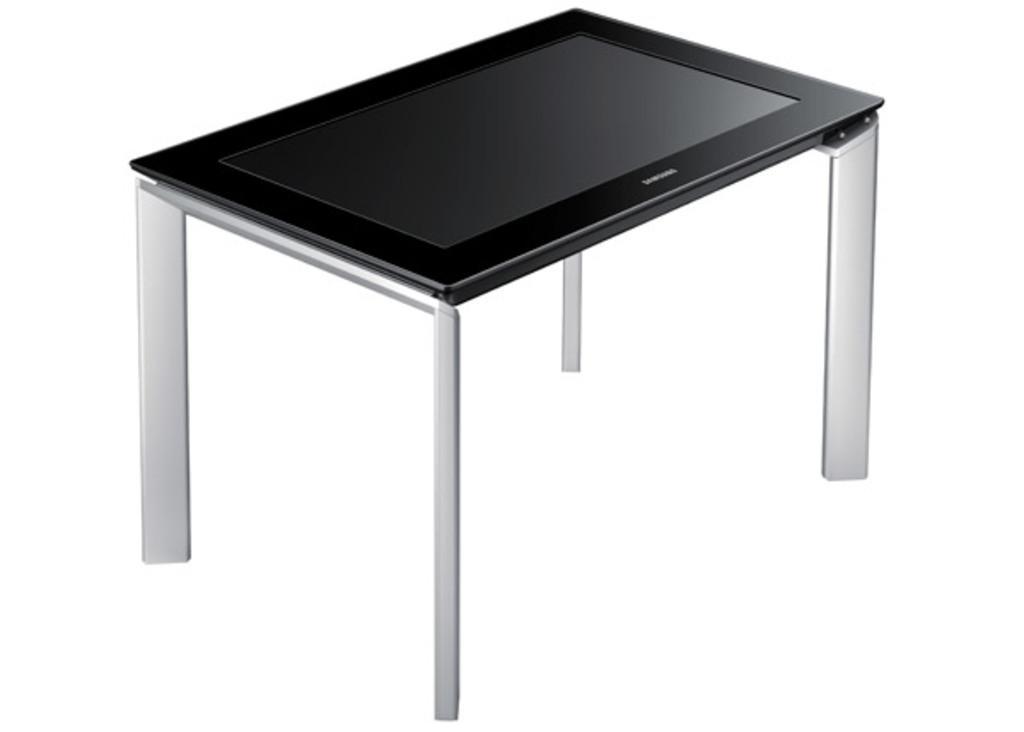In one or two sentences, can you explain what this image depicts? In this image there is a television on a stand. 